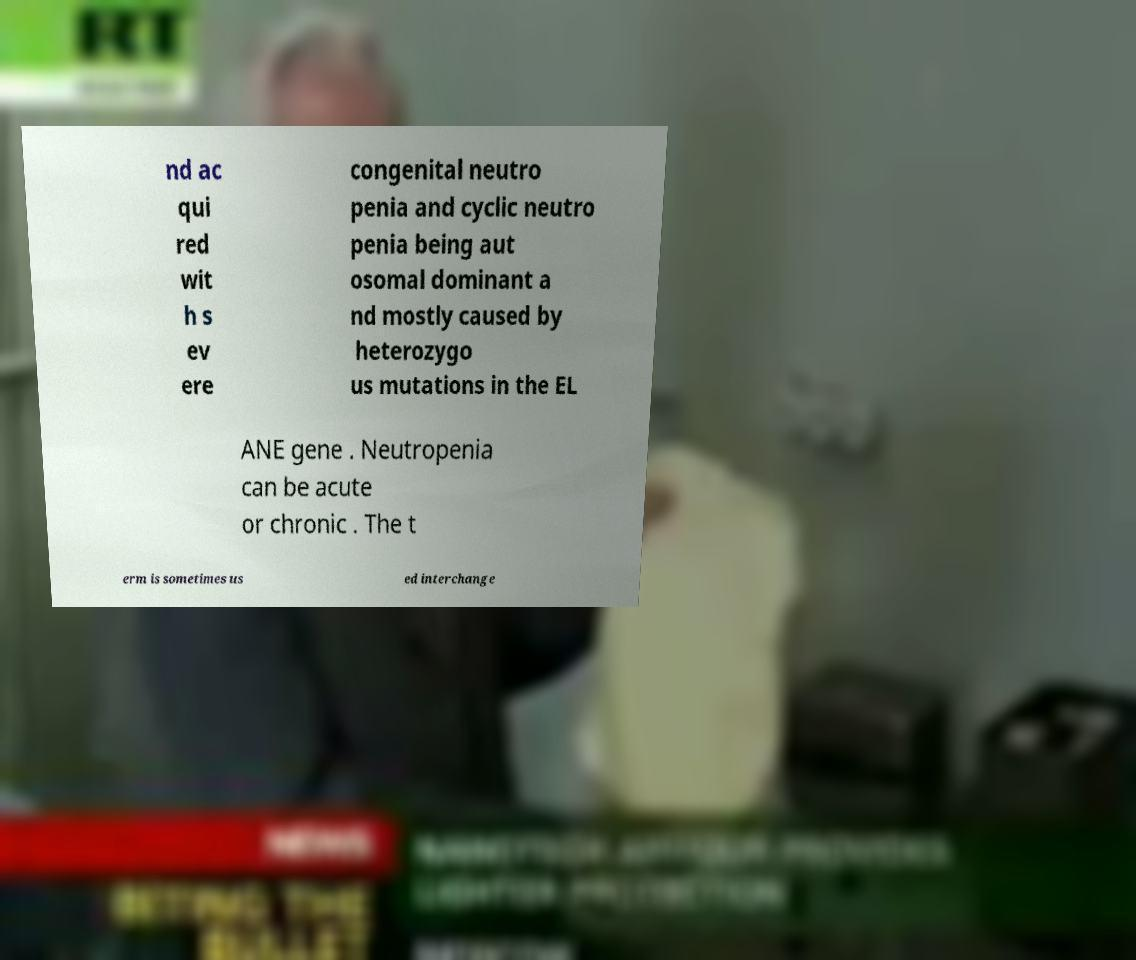I need the written content from this picture converted into text. Can you do that? nd ac qui red wit h s ev ere congenital neutro penia and cyclic neutro penia being aut osomal dominant a nd mostly caused by heterozygo us mutations in the EL ANE gene . Neutropenia can be acute or chronic . The t erm is sometimes us ed interchange 